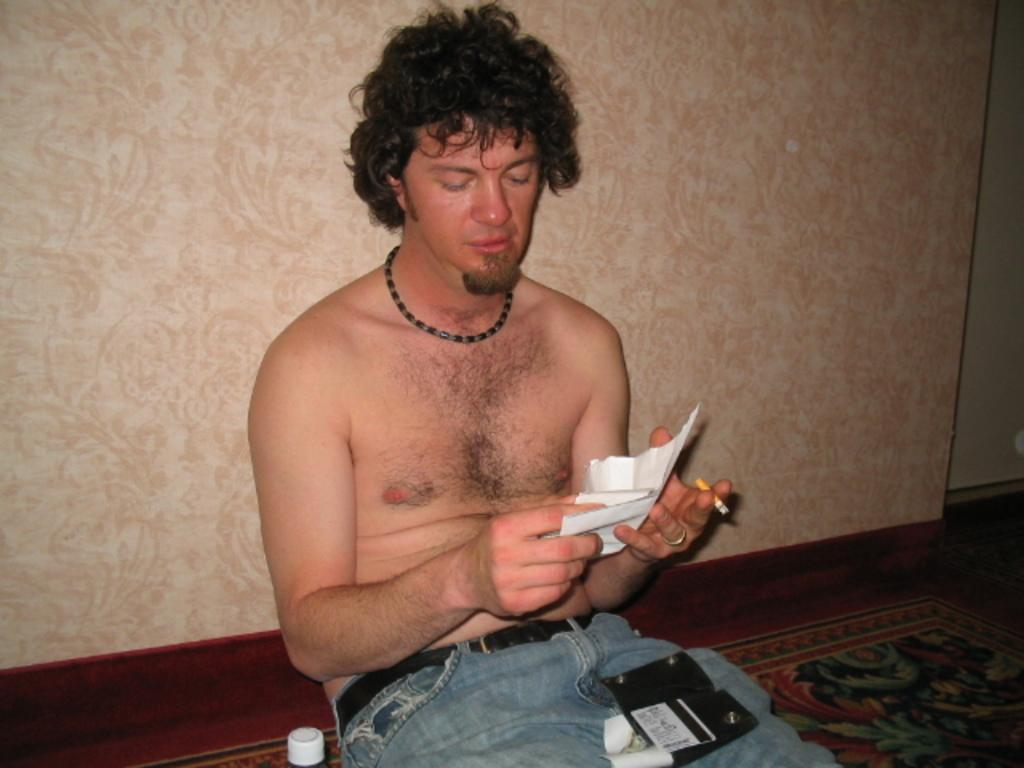Who is present in the image? There is a man in the image. What is the man doing in the image? The man is seated on the floor. What is the man holding in his hands? The man is holding a cigarette and a paper. What type of sugar is visible on the man's face in the image? There is no sugar visible on the man's face in the image. 